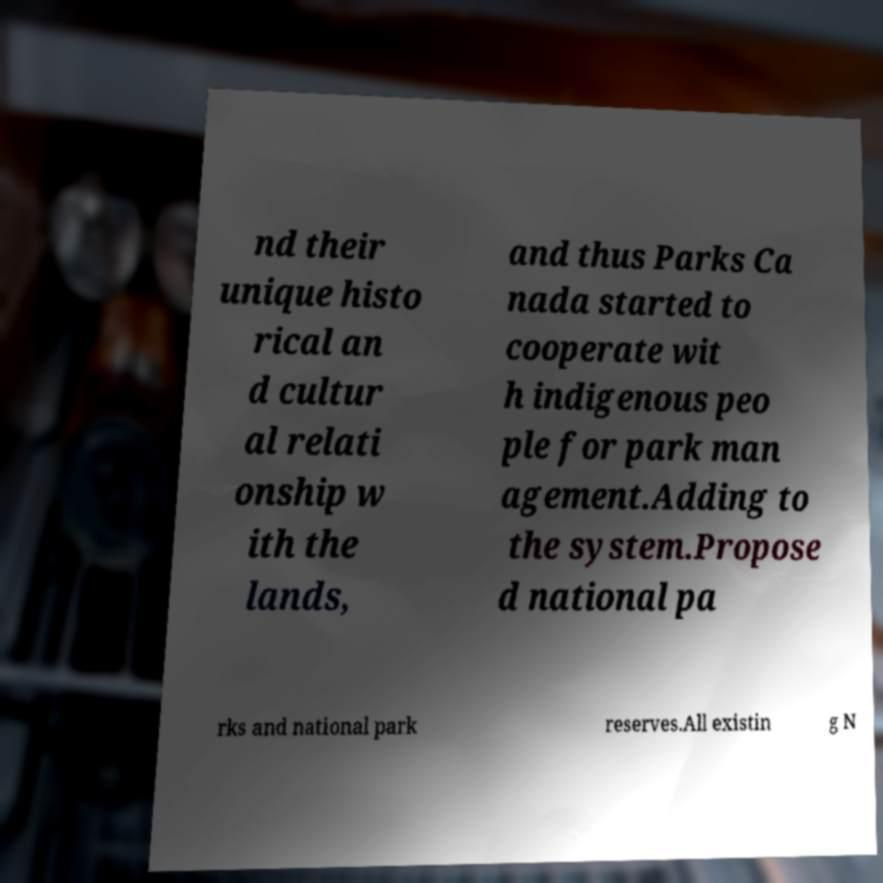For documentation purposes, I need the text within this image transcribed. Could you provide that? nd their unique histo rical an d cultur al relati onship w ith the lands, and thus Parks Ca nada started to cooperate wit h indigenous peo ple for park man agement.Adding to the system.Propose d national pa rks and national park reserves.All existin g N 